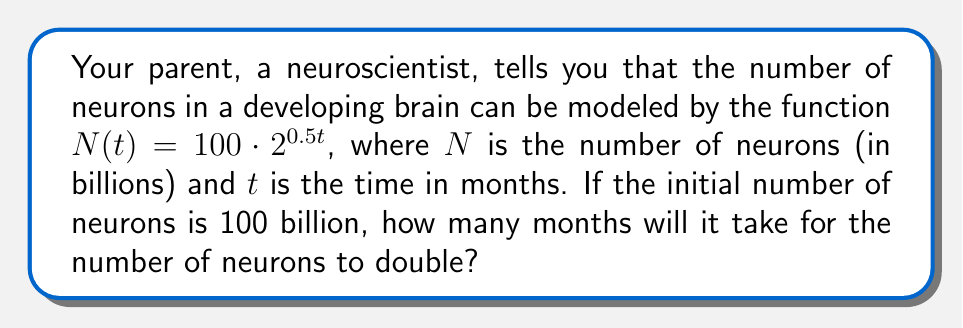What is the answer to this math problem? Let's approach this step-by-step:

1) We're given the exponential function: $N(t) = 100 \cdot 2^{0.5t}$

2) We want to find when the number of neurons doubles. This means we're looking for the time $t$ when $N(t) = 200$ billion (twice the initial 100 billion).

3) Let's set up the equation:
   
   $200 = 100 \cdot 2^{0.5t}$

4) Divide both sides by 100:
   
   $2 = 2^{0.5t}$

5) Now, we can use logarithms to solve for $t$. Let's use log base 2 on both sides:

   $\log_2(2) = \log_2(2^{0.5t})$

6) The left side simplifies to 1, and we can use the logarithm property on the right side:

   $1 = 0.5t \cdot \log_2(2)$

7) $\log_2(2) = 1$, so our equation becomes:

   $1 = 0.5t$

8) Now we can solve for $t$:

   $t = 1 / 0.5 = 2$

Therefore, it will take 2 months for the number of neurons to double.
Answer: 2 months 